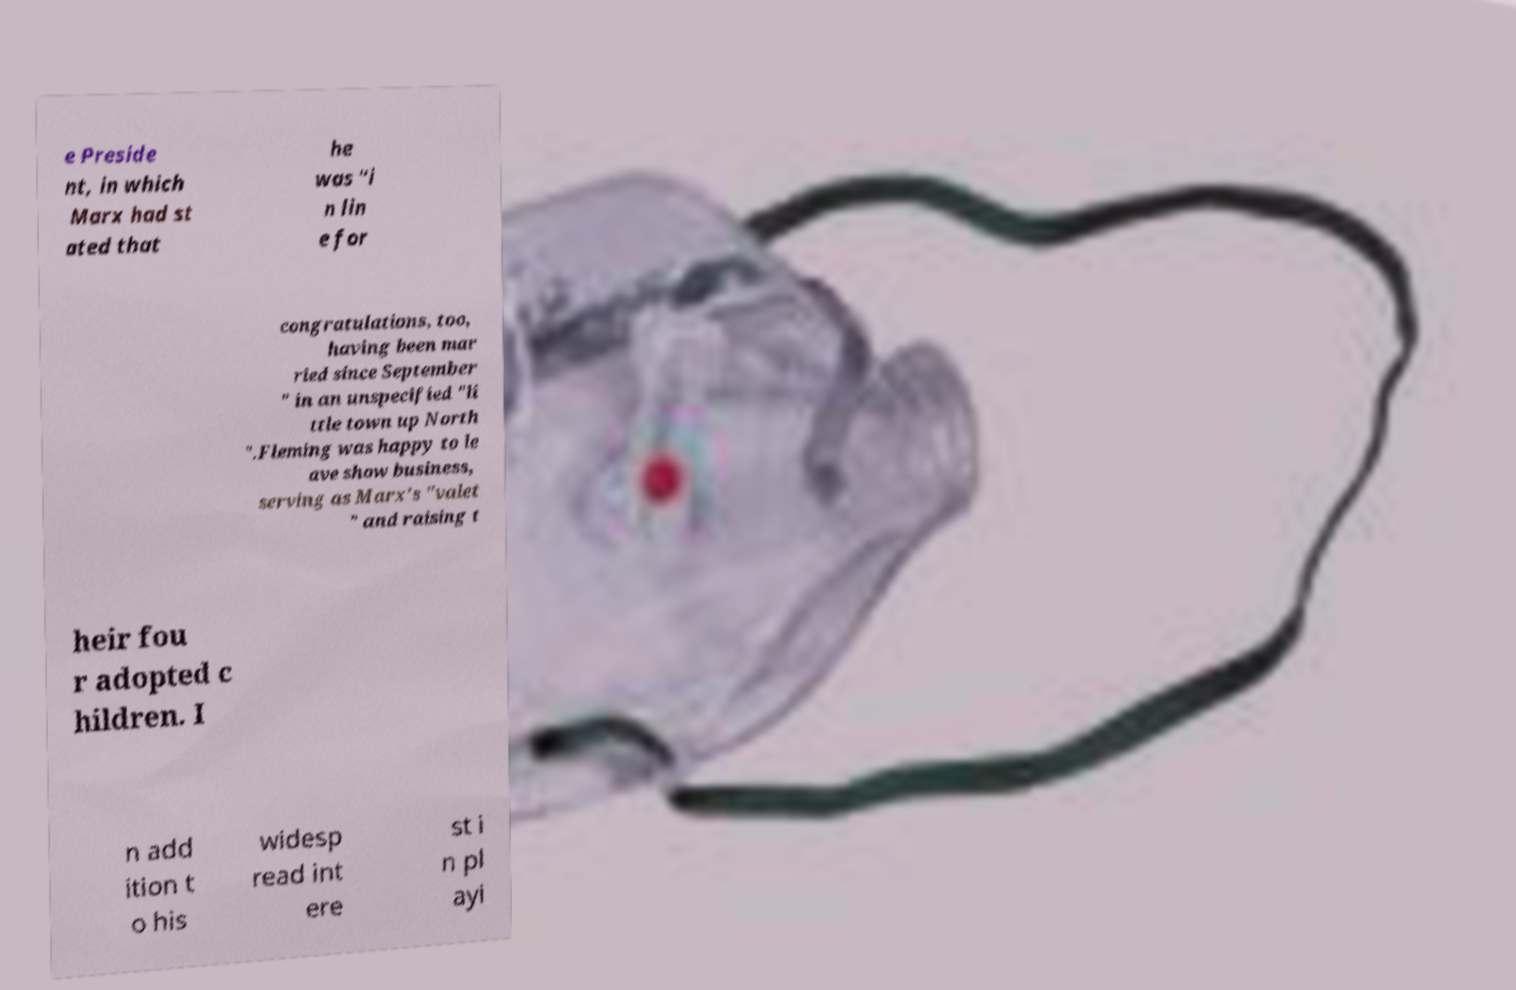Can you accurately transcribe the text from the provided image for me? e Preside nt, in which Marx had st ated that he was "i n lin e for congratulations, too, having been mar ried since September " in an unspecified "li ttle town up North ".Fleming was happy to le ave show business, serving as Marx's "valet " and raising t heir fou r adopted c hildren. I n add ition t o his widesp read int ere st i n pl ayi 